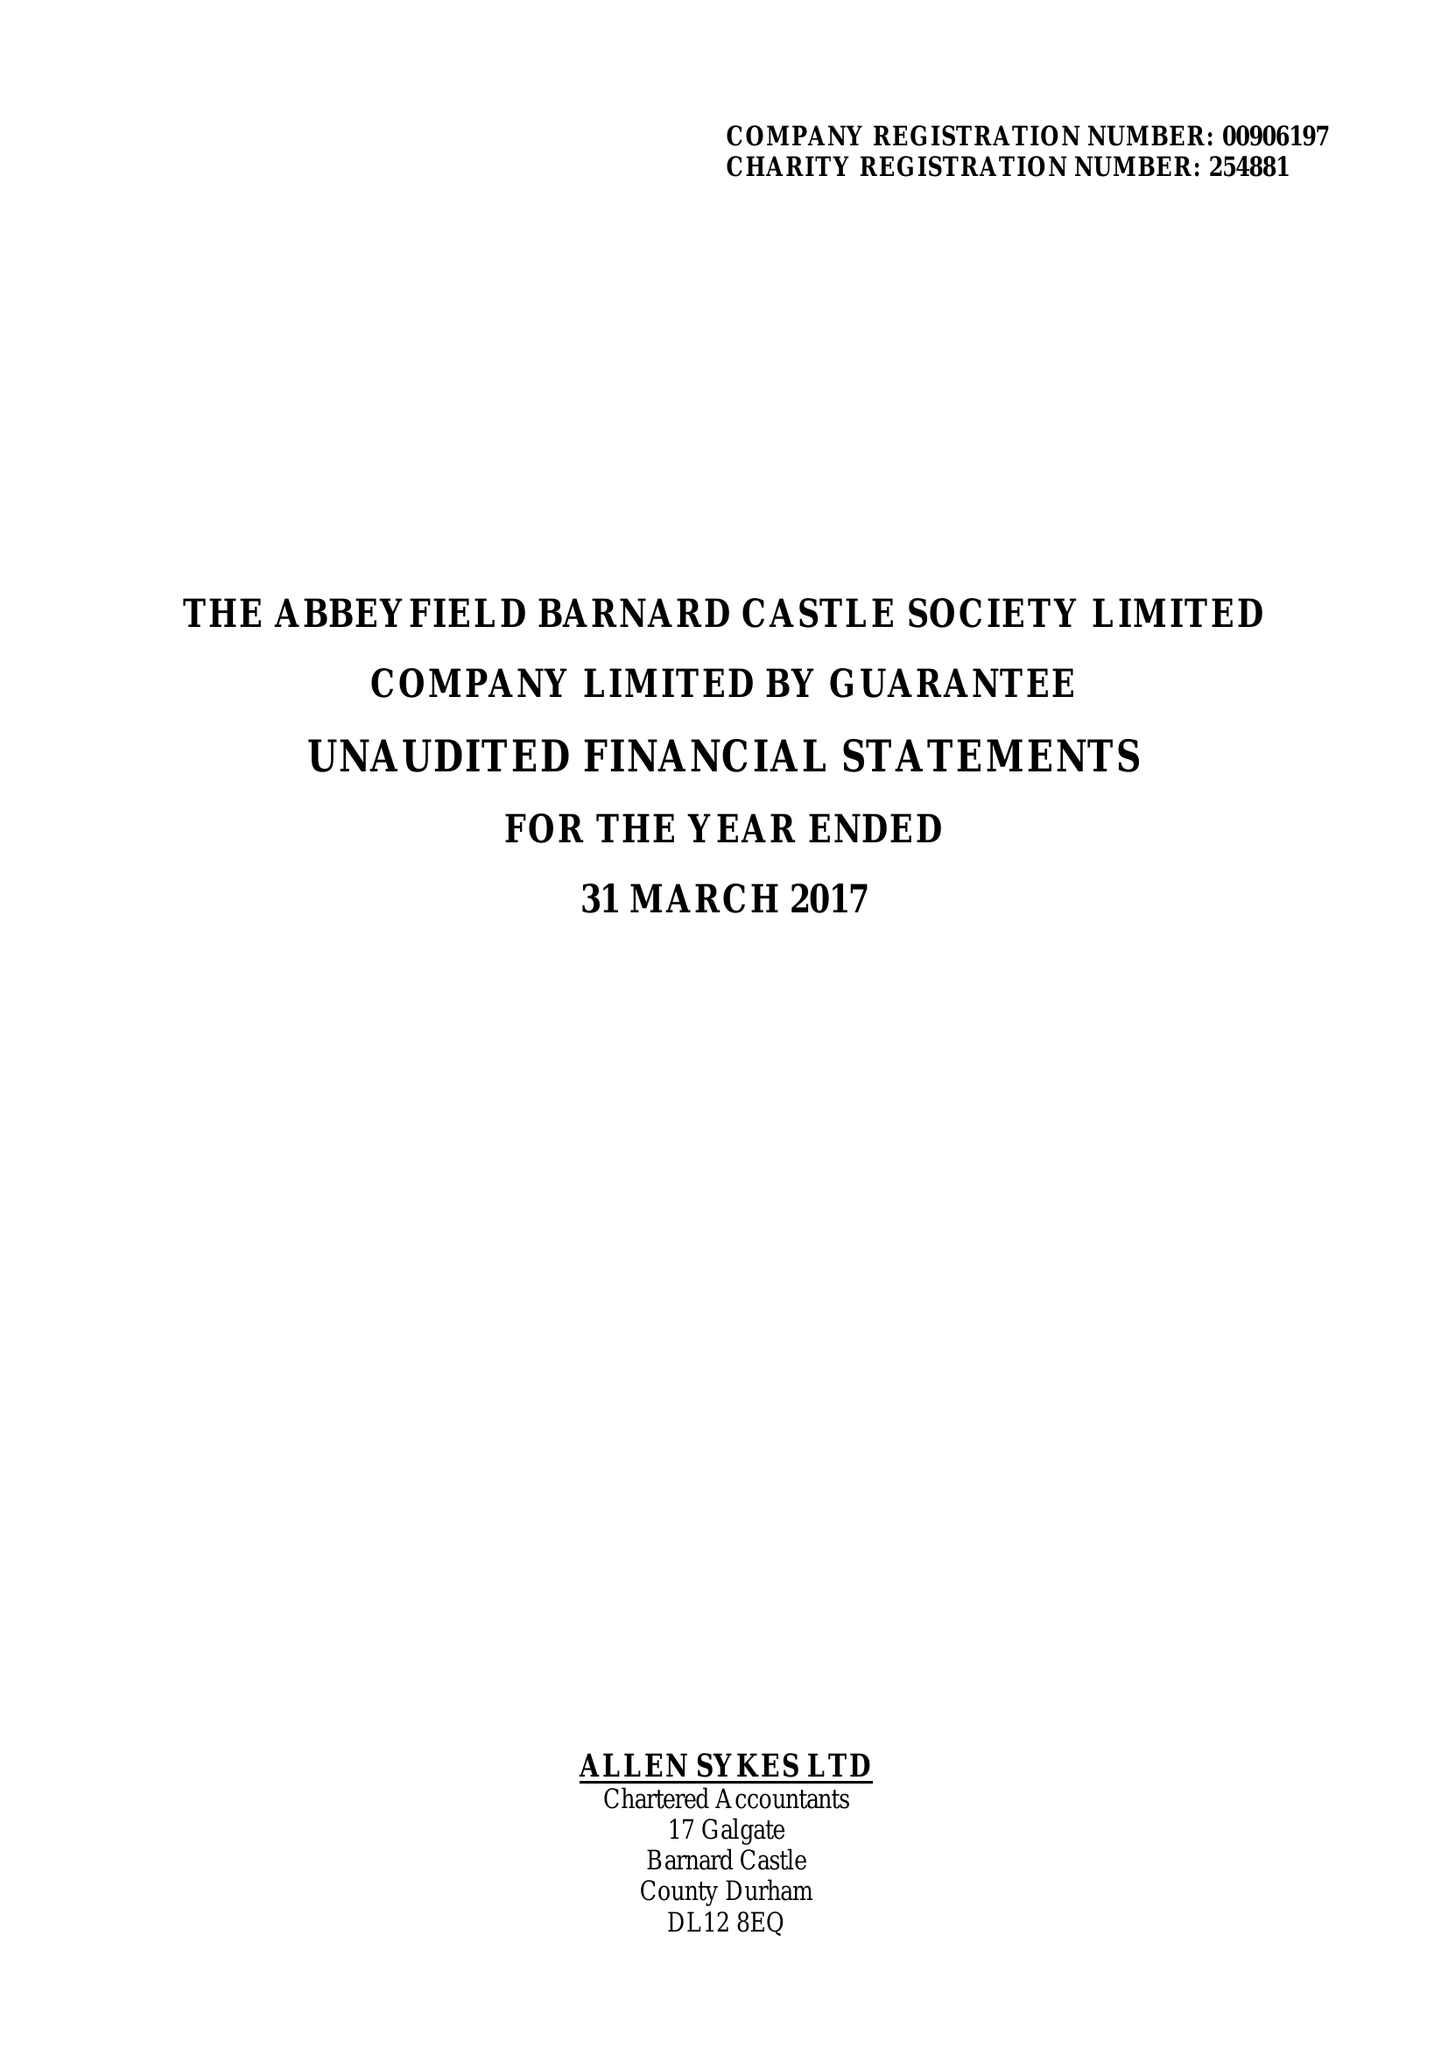What is the value for the income_annually_in_british_pounds?
Answer the question using a single word or phrase. 252383.00 